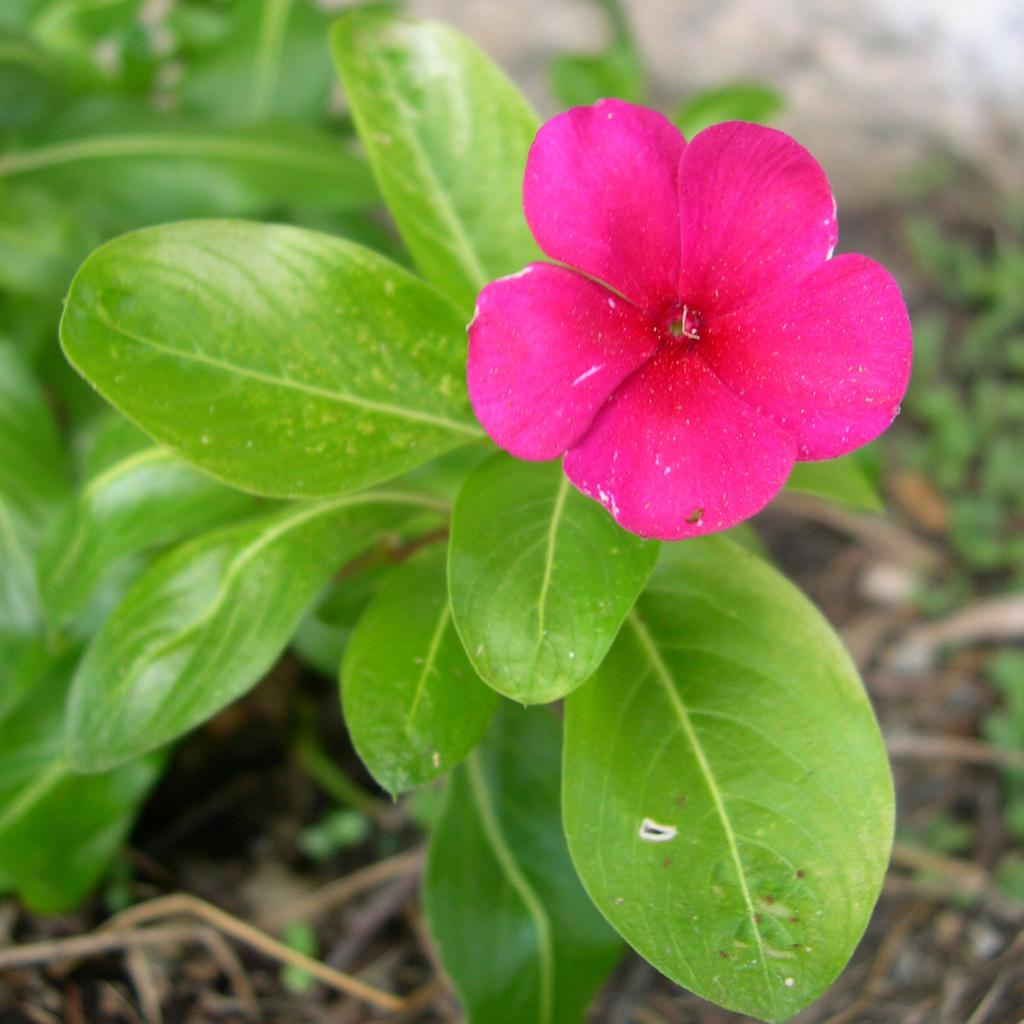What type of plant is visible in the image? There is a flower in the image. What other type of plant can be seen in the image? There is a plant in the image. Can you describe the background of the image? The background of the image is blurry. What type of structure can be seen in the image? There is no structure present in the image; it features a flower and a plant. Can you tell me how many dogs are visible in the image? There are no dogs present in the image. What type of clothing is worn by the flower in the image? The flower is a plant and does not wear clothing like a skirt. 